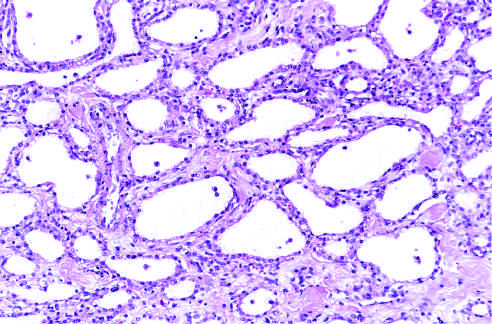what are lined by cuboidal epithelium without atypia?
Answer the question using a single word or phrase. The cysts 